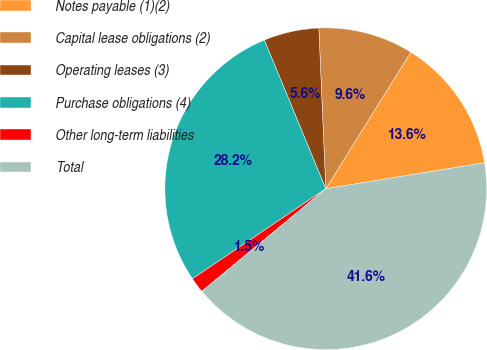Convert chart to OTSL. <chart><loc_0><loc_0><loc_500><loc_500><pie_chart><fcel>Notes payable (1)(2)<fcel>Capital lease obligations (2)<fcel>Operating leases (3)<fcel>Purchase obligations (4)<fcel>Other long-term liabilities<fcel>Total<nl><fcel>13.55%<fcel>9.55%<fcel>5.55%<fcel>28.22%<fcel>1.54%<fcel>41.59%<nl></chart> 